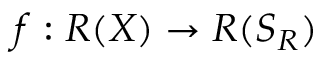Convert formula to latex. <formula><loc_0><loc_0><loc_500><loc_500>f \colon R ( X ) \rightarrow R ( S _ { R } )</formula> 